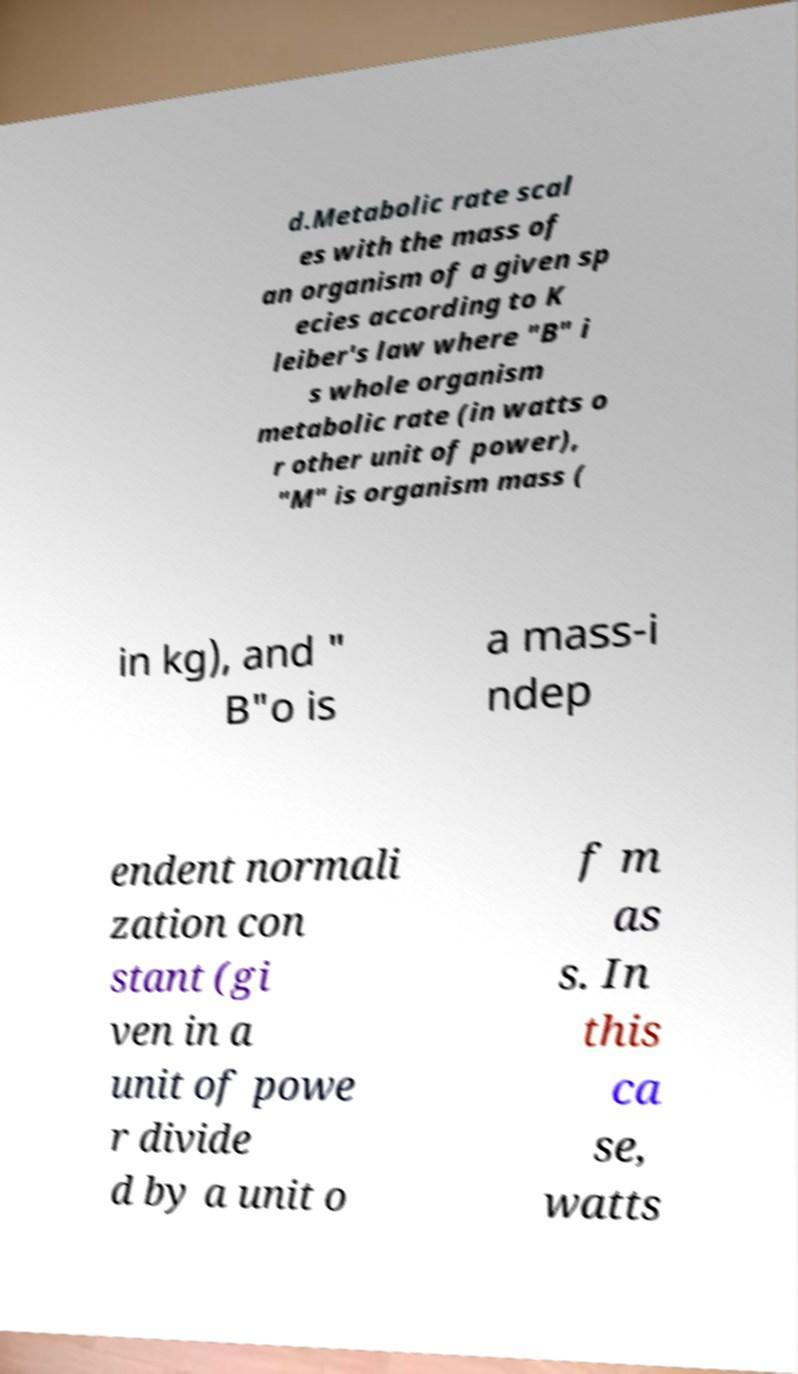For documentation purposes, I need the text within this image transcribed. Could you provide that? d.Metabolic rate scal es with the mass of an organism of a given sp ecies according to K leiber's law where "B" i s whole organism metabolic rate (in watts o r other unit of power), "M" is organism mass ( in kg), and " B"o is a mass-i ndep endent normali zation con stant (gi ven in a unit of powe r divide d by a unit o f m as s. In this ca se, watts 